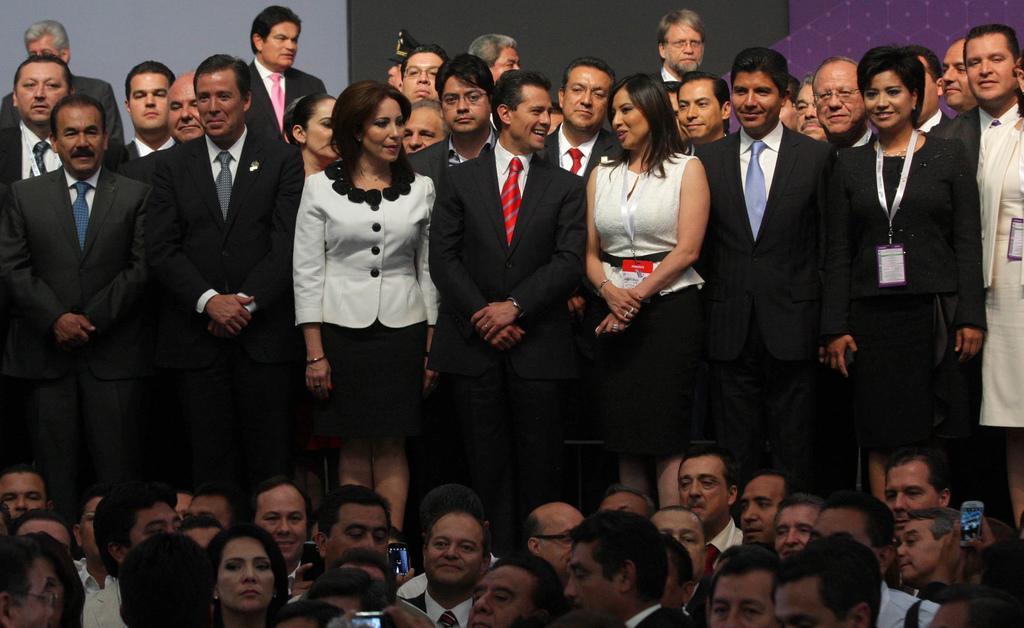Can you describe this image briefly? In this picture there are group of people standing. At the back it looks like a board. At the bottom there are group of people and few people are holding the cell phones. 